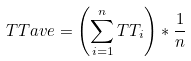Convert formula to latex. <formula><loc_0><loc_0><loc_500><loc_500>T T a v e = \left ( \sum _ { i = 1 } ^ { n } T T _ { i } \right ) * \frac { 1 } { n }</formula> 